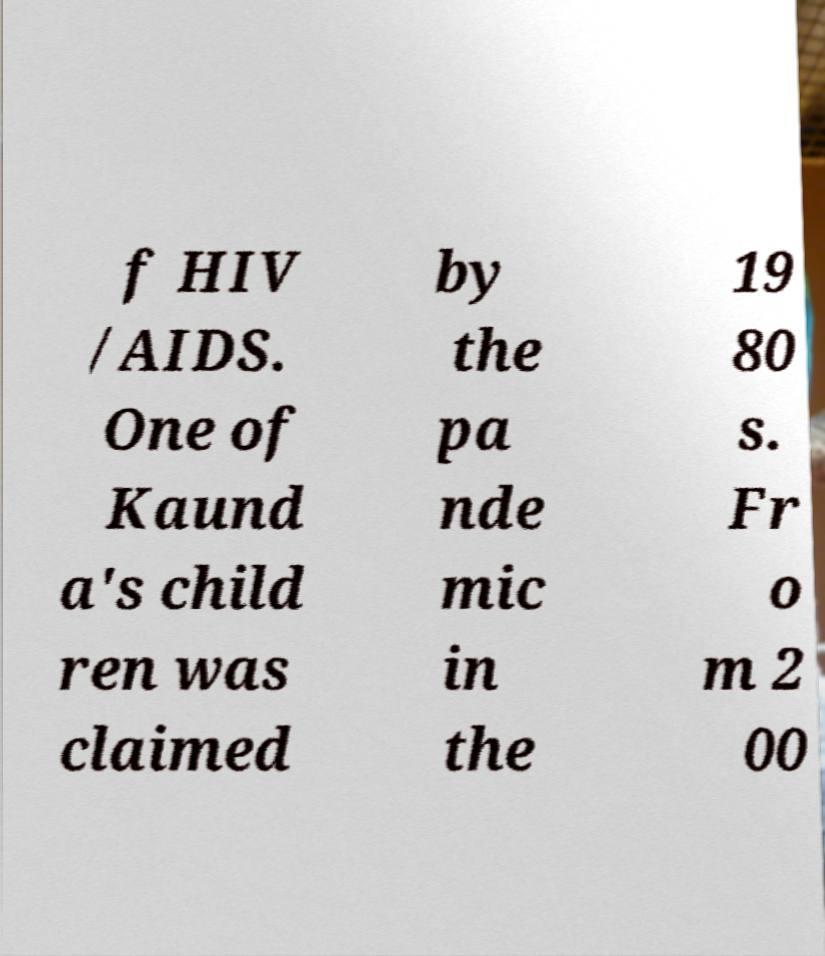Can you accurately transcribe the text from the provided image for me? f HIV /AIDS. One of Kaund a's child ren was claimed by the pa nde mic in the 19 80 s. Fr o m 2 00 